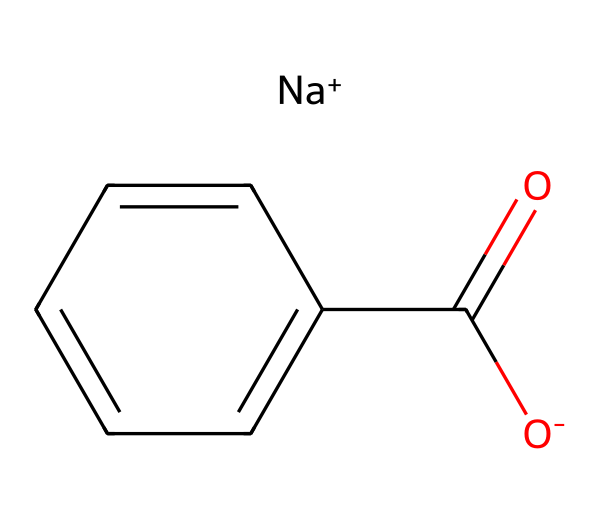What is the molecular formula of sodium benzoate? By analyzing the SMILES representation, the molecular formula can be deduced. The structure consists of 7 carbon atoms, 5 hydrogen atoms, 2 oxygen atoms, and one sodium atom. Therefore, the complete formula becomes C7H5O2Na.
Answer: C7H5O2Na How many carbon atoms are in sodium benzoate? The SMILES representation shows seven carbon atoms positioned in a chain (the phenyl ring and the carboxylate group). Counting these carbon atoms confirms this number.
Answer: 7 What is the charge of the sodium ion in sodium benzoate? In the SMILES representation, [Na+] denotes that sodium carries a positive charge. Therefore, the charge on the sodium ion is unambiguously positive.
Answer: positive How does the presence of the carboxylate group influence its preservative properties? The carboxylate group (-COO-) facilitates the compound's ability to inhibit microbial growth, which is essential for its function as a preservative. It does so by disrupting cellular processes of microbes, owing to its acidic nature and charge.
Answer: inhibit microbial growth What type of functional group is present in sodium benzoate? In the structure, the -COO- part (carboxylate group) is a clear indication of anionic carboxylic acid functional group, which is crucial for its preservation ability in food products.
Answer: carboxylate What is the significance of the phenyl ring in sodium benzoate? The presence of the phenyl ring is significant because it enhances the stability of the sodium benzoate and contributes to its aromatic nature, which can play a role in its sensory properties as a preservative, especially in snacks.
Answer: enhances stability How does sodium benzoate dissociate in water? In an aqueous environment, sodium benzoate dissociates into sodium ions (Na+) and benzoate ions (C6H5COO-), which affects its solubility and effectiveness as a preservative. This can be inferred from the structure showing the ionic forms.
Answer: into sodium ions and benzoate ions 